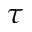<formula> <loc_0><loc_0><loc_500><loc_500>\tau</formula> 